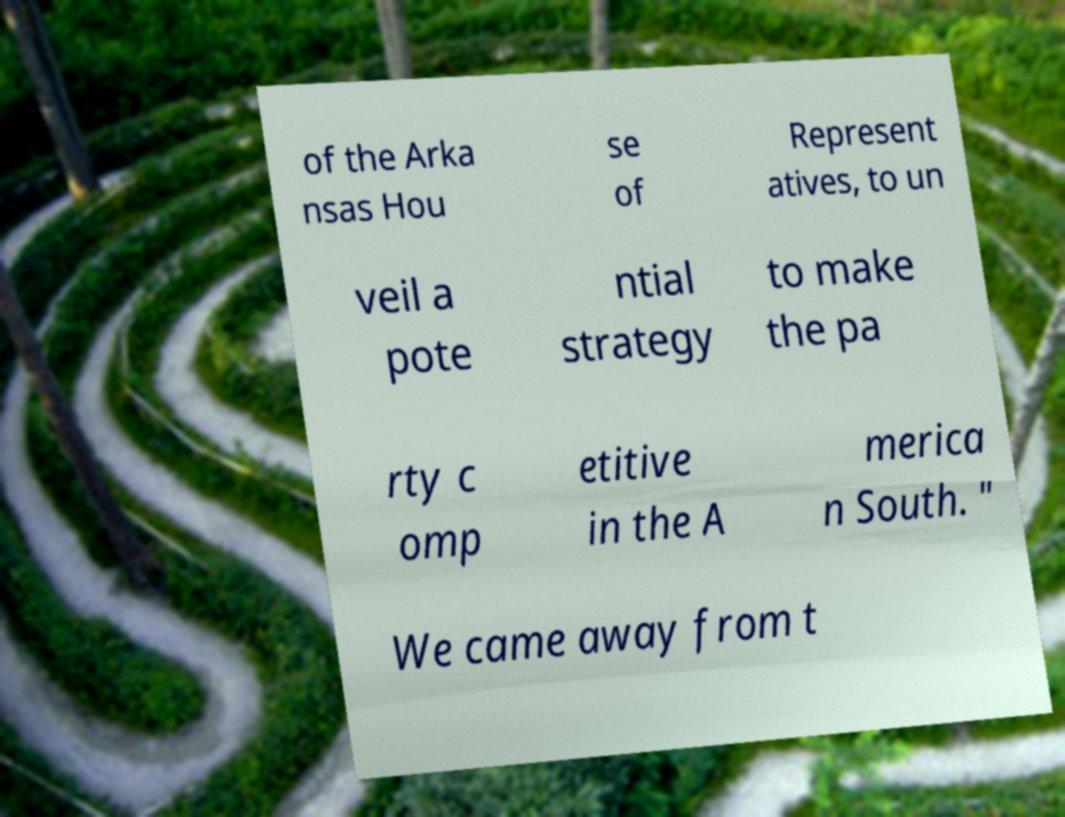Could you assist in decoding the text presented in this image and type it out clearly? of the Arka nsas Hou se of Represent atives, to un veil a pote ntial strategy to make the pa rty c omp etitive in the A merica n South. " We came away from t 